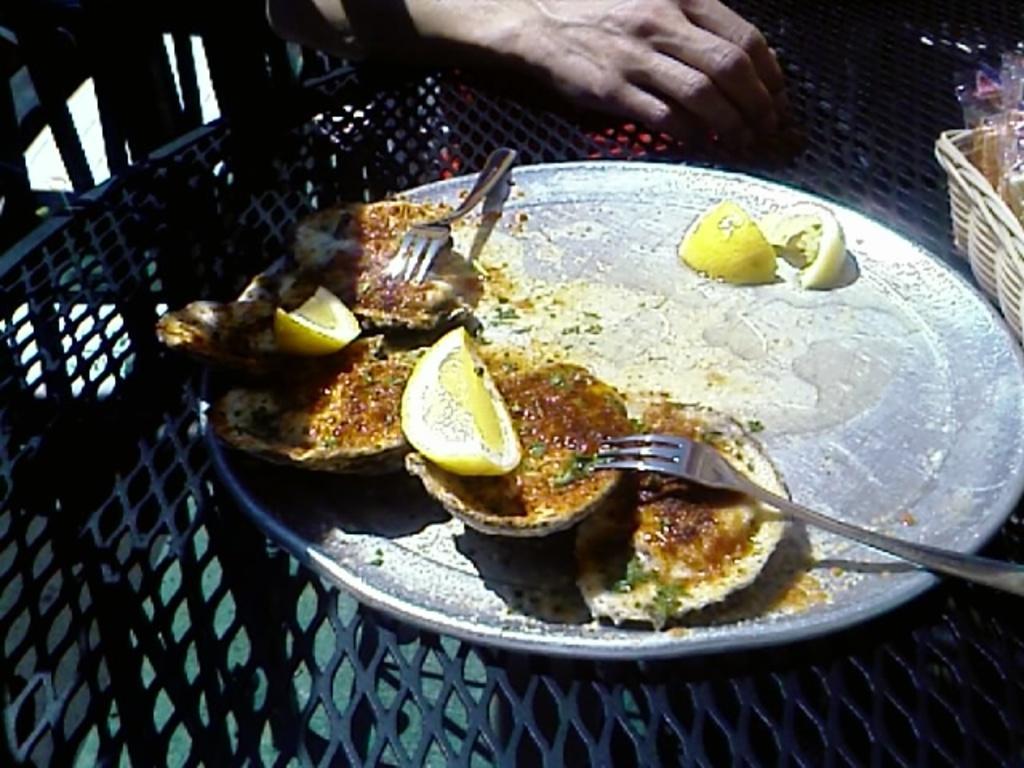How would you summarize this image in a sentence or two? In the image there is some food item kept on a plate and the plate is kept on some object, behind the plate there is a hand. On the right side there is a basket and in that there are some items. 